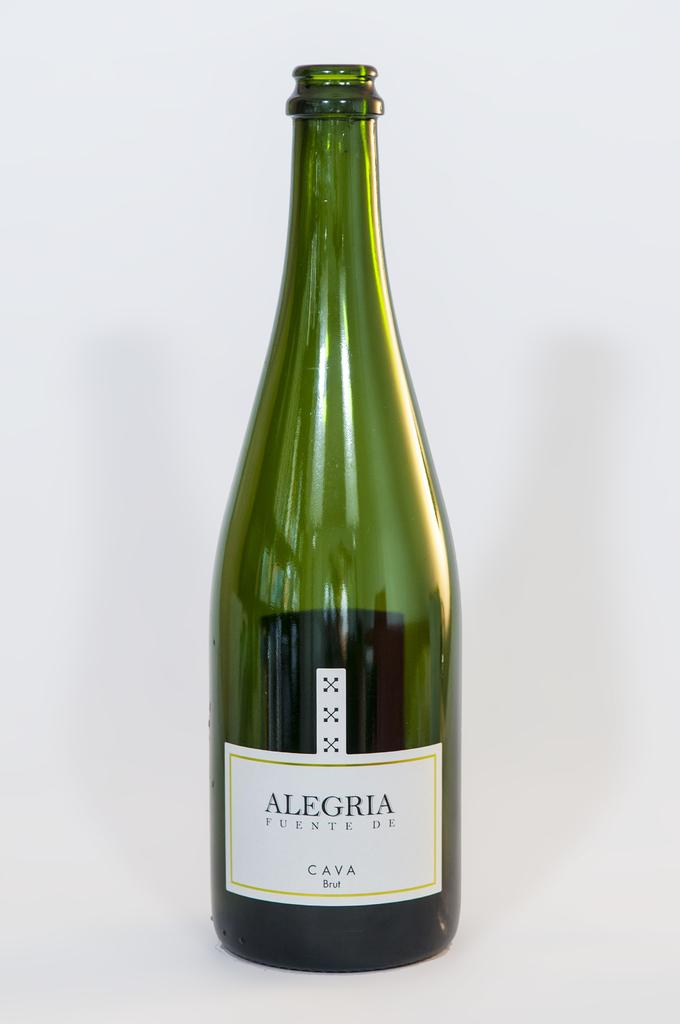<image>
Summarize the visual content of the image. An opened green bottle of Alegria Funete De. 